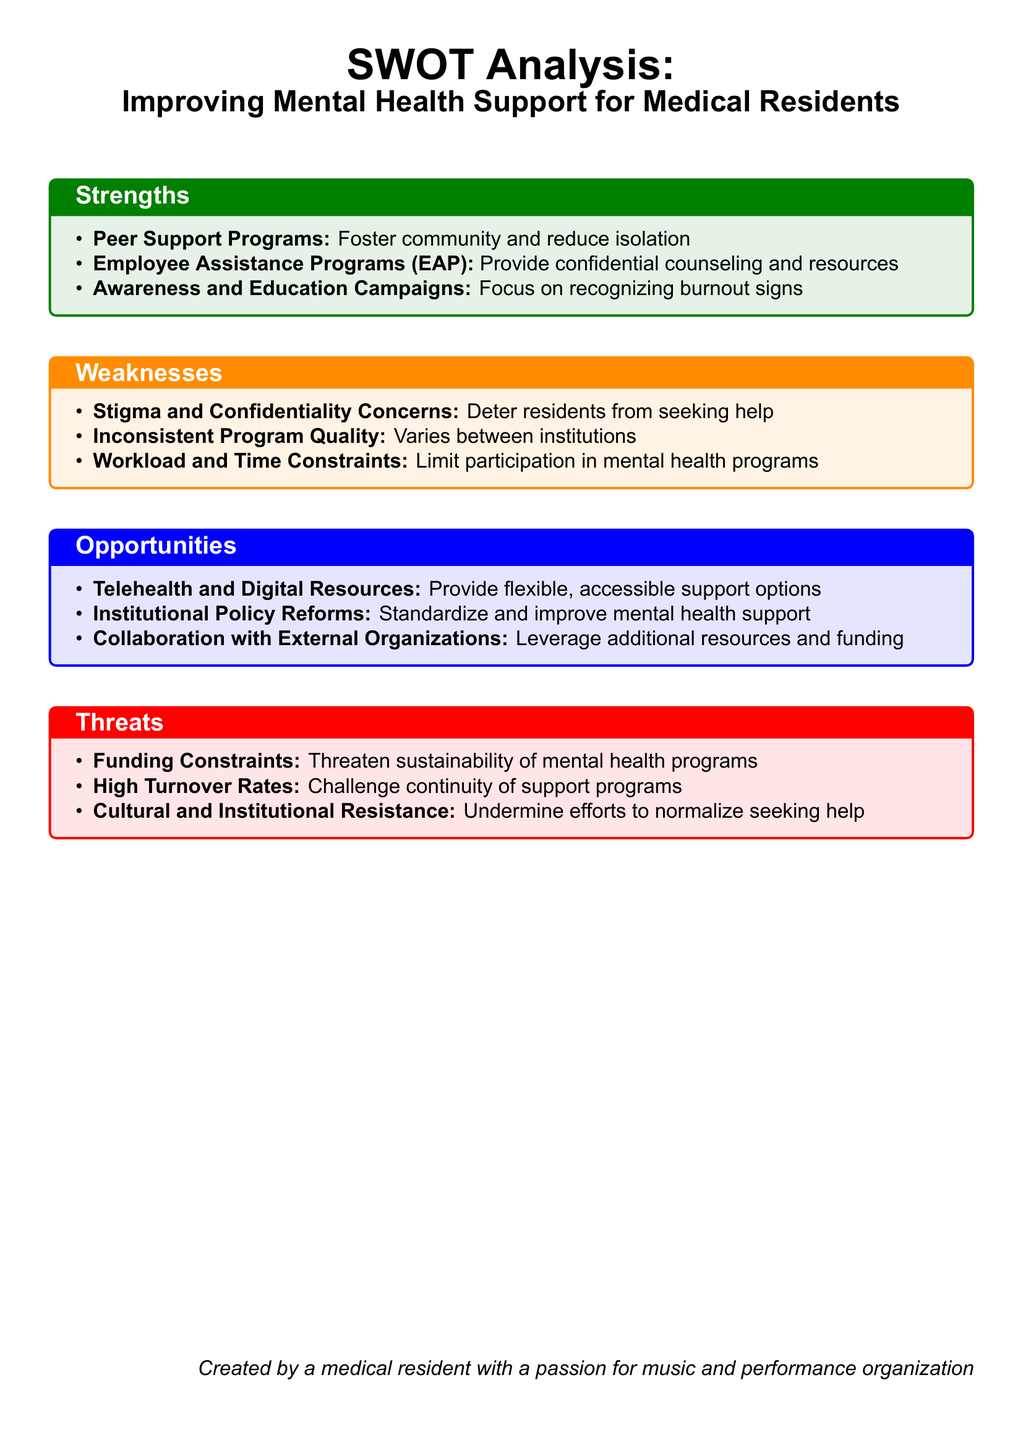What is one strength of improving mental health support for medical residents? The document lists peer support programs as a strength, which foster community and reduce isolation.
Answer: Peer Support Programs What are the weaknesses highlighted in the analysis? The document mentions stigma and confidentiality concerns, inconsistent program quality, and workload and time constraints as weaknesses.
Answer: Stigma and Confidentiality Concerns What opportunity involves technology in mental health support? Telehealth and digital resources are identified as an opportunity for flexible and accessible support options in the document.
Answer: Telehealth and Digital Resources How many threats to mental health support are identified? The document outlines three threats to mental health support programs for medical residents.
Answer: Three What is one of the threats mentioned in the analysis? The document specifically mentions funding constraints as a threat to the sustainability of mental health programs.
Answer: Funding Constraints Which program provides confidential counseling for residents? Employee Assistance Programs (EAP) provide confidential counseling and resources according to the document.
Answer: Employee Assistance Programs (EAP) What type of resistance poses a threat to mental health support normalization? Cultural and institutional resistance is mentioned in the document as undermining efforts to normalize seeking help.
Answer: Cultural and Institutional Resistance 